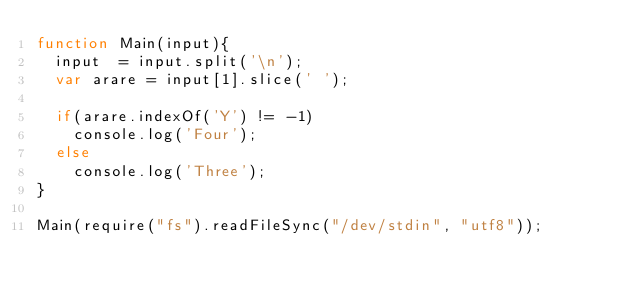<code> <loc_0><loc_0><loc_500><loc_500><_JavaScript_>function Main(input){
  input  = input.split('\n');
  var arare = input[1].slice(' ');

  if(arare.indexOf('Y') != -1)
    console.log('Four');
  else
    console.log('Three');
}

Main(require("fs").readFileSync("/dev/stdin", "utf8"));
</code> 